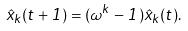Convert formula to latex. <formula><loc_0><loc_0><loc_500><loc_500>\hat { x } _ { k } ( t + 1 ) = ( \omega ^ { k } - 1 ) \hat { x } _ { k } ( t ) .</formula> 